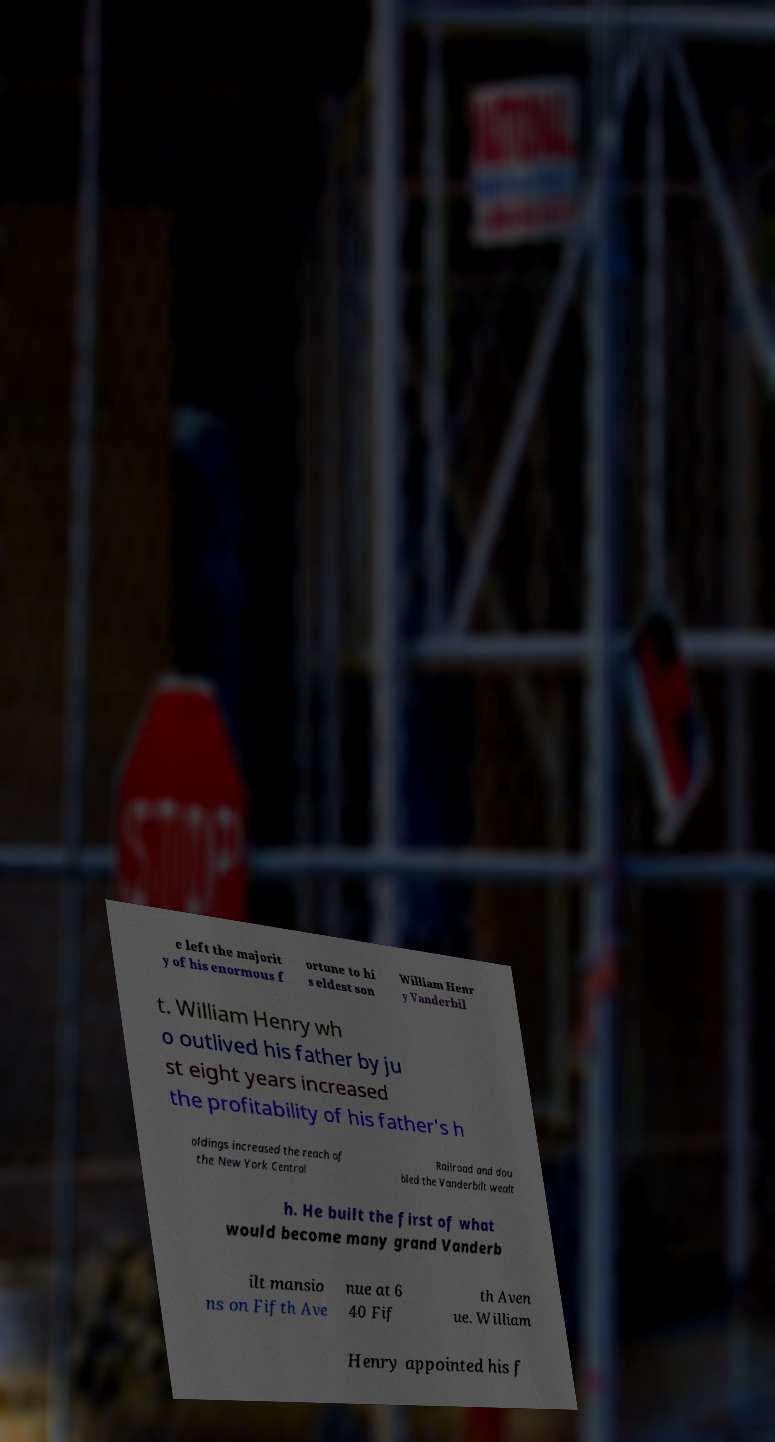What messages or text are displayed in this image? I need them in a readable, typed format. e left the majorit y of his enormous f ortune to hi s eldest son William Henr y Vanderbil t. William Henry wh o outlived his father by ju st eight years increased the profitability of his father's h oldings increased the reach of the New York Central Railroad and dou bled the Vanderbilt wealt h. He built the first of what would become many grand Vanderb ilt mansio ns on Fifth Ave nue at 6 40 Fif th Aven ue. William Henry appointed his f 